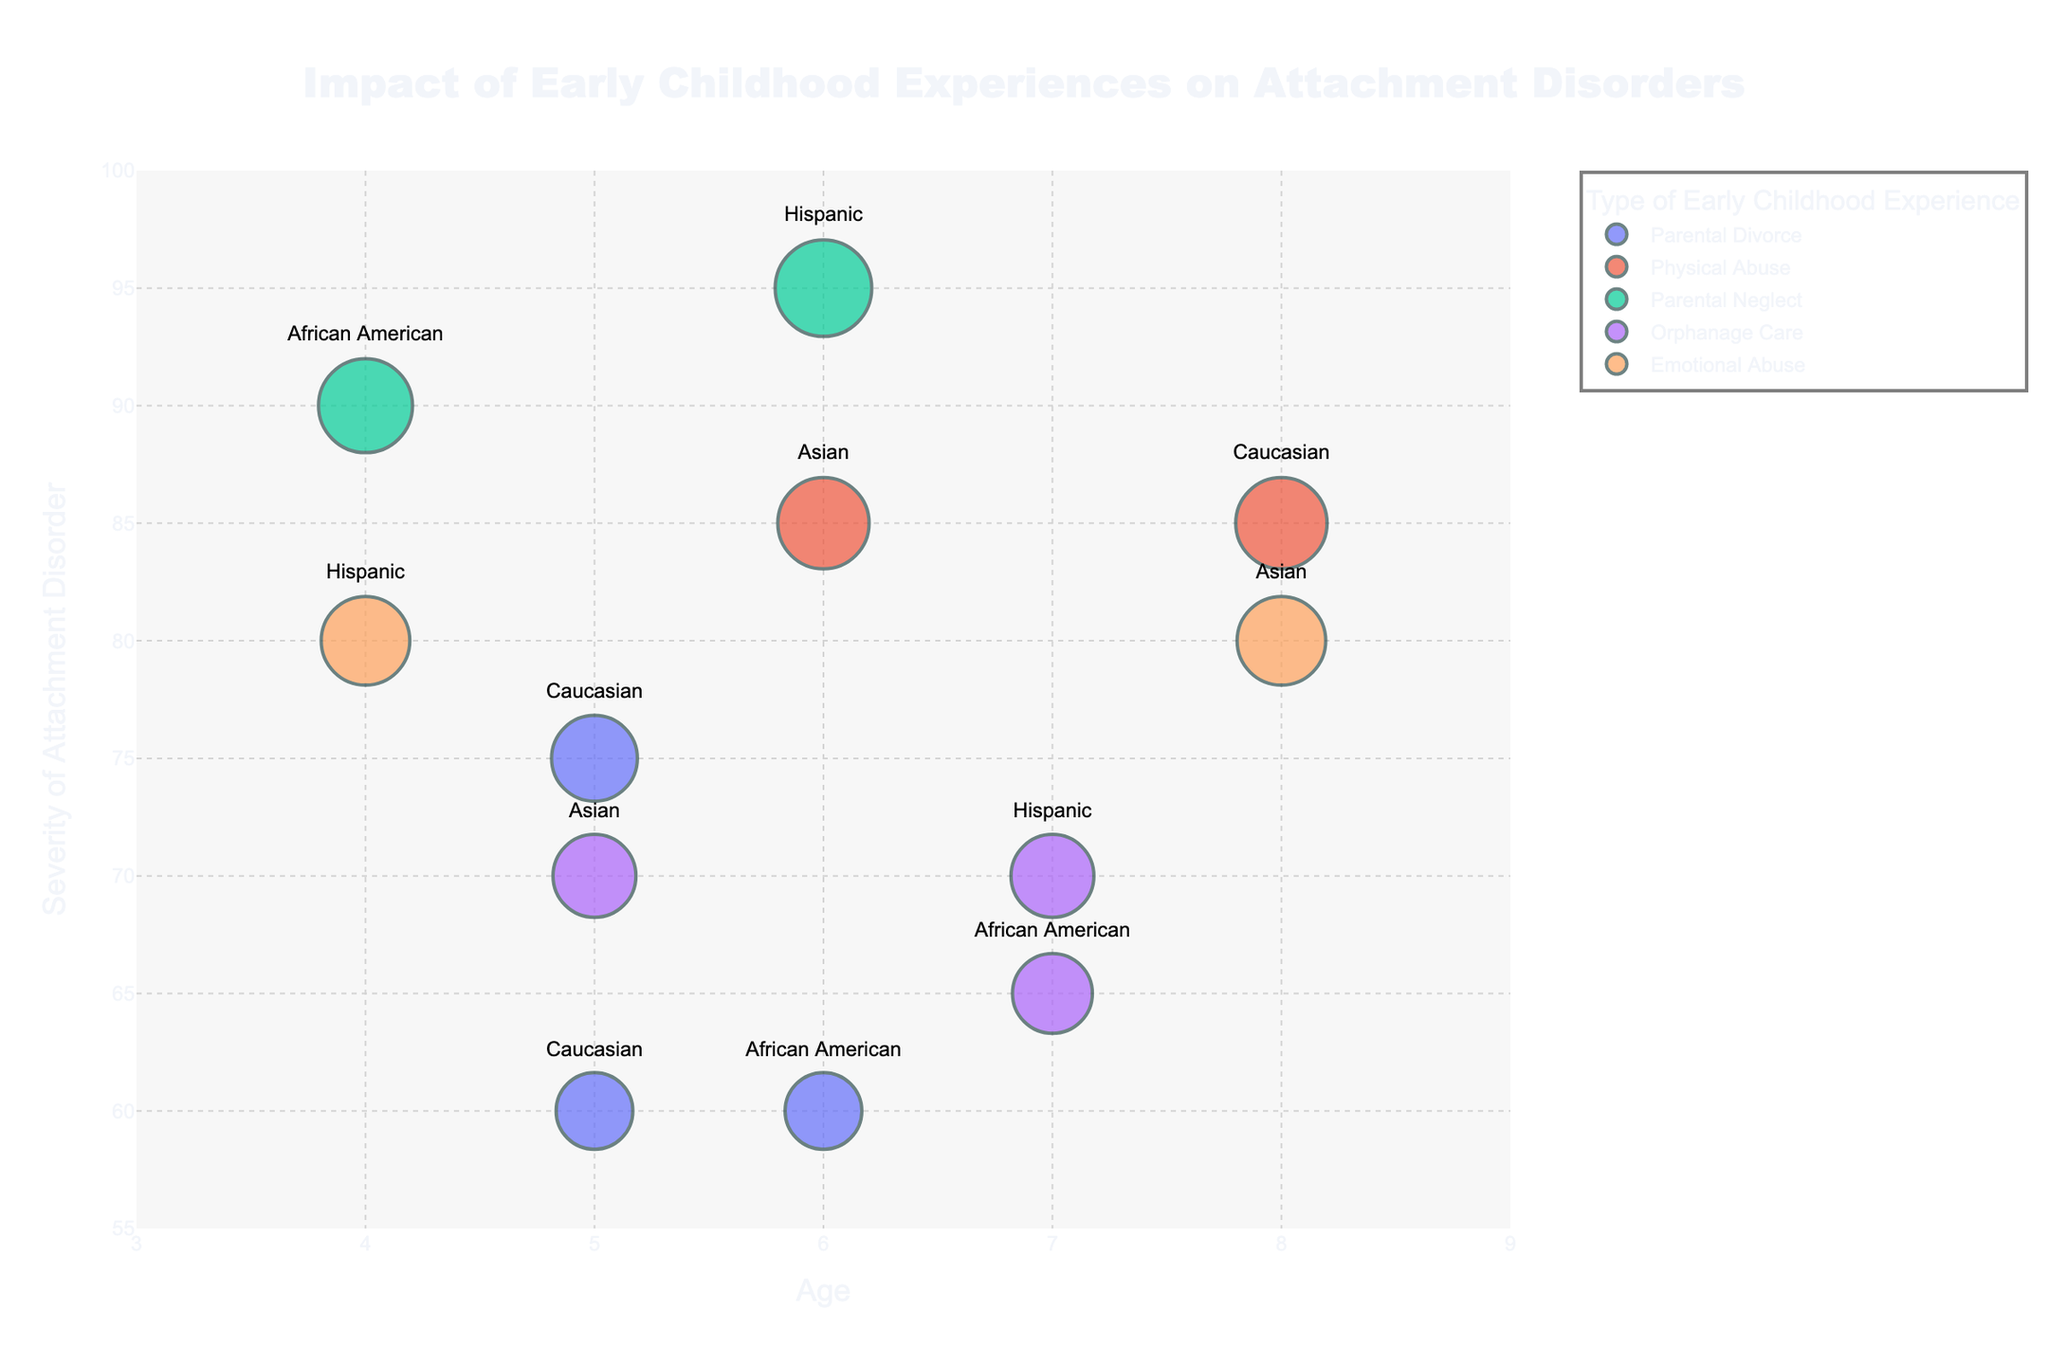what is the title of the chart? The title is located at the top center of the chart, and it reads "Impact of Early Childhood Experiences on Attachment Disorders".
Answer: Impact of Early Childhood Experiences on Attachment Disorders What is the highest severity of attachment disorders seen in the figure, and which type of early childhood experience is it associated with? To find the highest severity, identify the biggest bubble and check its y-coordinate. It is associated with 'Parental Neglect' which shows up at the highest point, which is 95.
Answer: Parental Neglect How does the severity of attachment disorders for children with 'Physical Abuse' differ between ages 6 and 8? Locate the bubbles associated with 'Physical Abuse'. One child is aged 6, and the other 8; their severities are 85 for both ages. So, there is no difference.
Answer: No difference Which ethnicity has the lowest severity of attachment disorder, and what is the severity level? Find the smallest bubble low on the y-axis, which belongs to 'Caucasian' at a severity level of 60.
Answer: Caucasian, 60 How many children experienced 'Orphanage Care' and what is the range of their attachment disorder severities? Count the bubbles associated with 'Orphanage Care' and check their y-coordinates: there are three data points (70, 65, and 70). The range is from 65 to 70.
Answer: Three children, range is 65 to 70 Compare the average severity of attachment disorders between males and females. Extract the severities for males and females and calculate their averages. Males have severities 75, 90, 80, 95, 85, 70. Females have severities 85, 70, 60, 65, 80, 60. Averages are calculated as (75+90+80+95+85+70)/6 = 82.5 for males and (85+70+60+65+80+60)/6 = 70 for females.
Answer: 82.5 for males, 70 for females Which type of early childhood experience is associated with the widest range of attachment disorder severity levels? Evaluate the range of severity levels for each experience type. 'Parental Neglect' ranges from 90 to 95, 'Emotional Abuse' from 80 to 80, 'Orphanage Care' from 65 to 70, 'Parental Divorce' from 60 to 75, 'Physical Abuse' from 85 to 85. 'Parental Divorce' holds the widest range.
Answer: Parental Divorce What is the age of the child with the highest severity of attachment disorder? Find the data point with the highest y-coordinate (severity of 95) and check its x-coordinate (age).
Answer: Age 6 Which type of early childhood experience has the largest severity bubble at age 5? Look for the largest bubble at age 5 on the x-axis. The largest bubble is associated with 'Parental Divorce' having a severity of 75.
Answer: Parental Divorce 